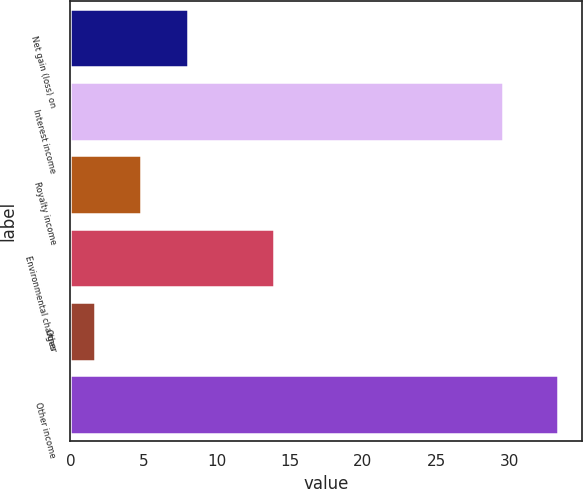Convert chart to OTSL. <chart><loc_0><loc_0><loc_500><loc_500><bar_chart><fcel>Net gain (loss) on<fcel>Interest income<fcel>Royalty income<fcel>Environmental charges<fcel>Other<fcel>Other income<nl><fcel>8.02<fcel>29.6<fcel>4.86<fcel>13.9<fcel>1.7<fcel>33.3<nl></chart> 